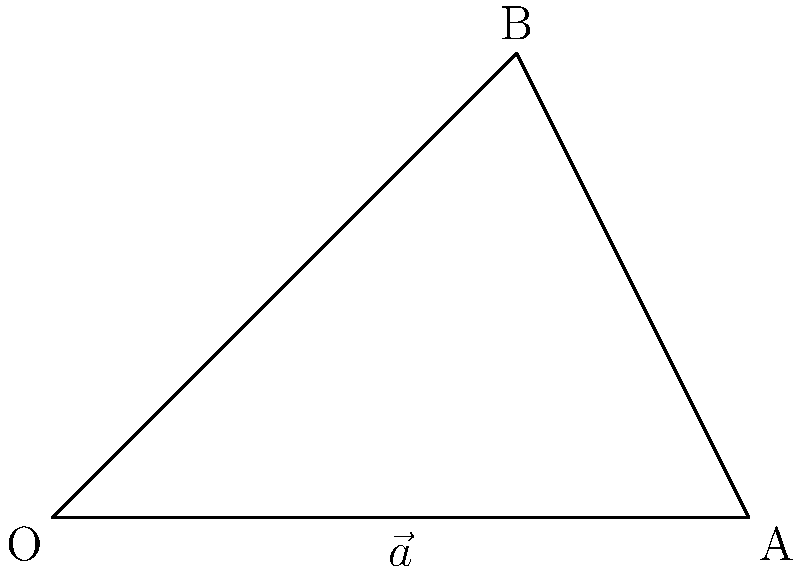As the father of the bride known for your smooth dance moves, you're helping the wedding planner choreograph a group dance. Two dance formations are represented by vectors $\vec{a}$ and $\vec{b}$, where $\vec{a} = 3\hat{i}$ and $\vec{b} = 2\hat{i} + 2\hat{j}$. What is the angle $\theta$ between these two vectors? To find the angle between two vectors, we can use the dot product formula:

$$\cos \theta = \frac{\vec{a} \cdot \vec{b}}{|\vec{a}||\vec{b}|}$$

Step 1: Calculate the dot product $\vec{a} \cdot \vec{b}$
$\vec{a} \cdot \vec{b} = (3)(2) + (0)(2) = 6$

Step 2: Calculate the magnitudes of $\vec{a}$ and $\vec{b}$
$|\vec{a}| = \sqrt{3^2 + 0^2} = 3$
$|\vec{b}| = \sqrt{2^2 + 2^2} = 2\sqrt{2}$

Step 3: Substitute into the formula
$$\cos \theta = \frac{6}{3(2\sqrt{2})} = \frac{\sqrt{2}}{2}$$

Step 4: Take the inverse cosine (arccos) of both sides
$$\theta = \arccos(\frac{\sqrt{2}}{2})$$

Step 5: Calculate the result
$\theta \approx 0.7854$ radians or $45°$
Answer: $45°$ 